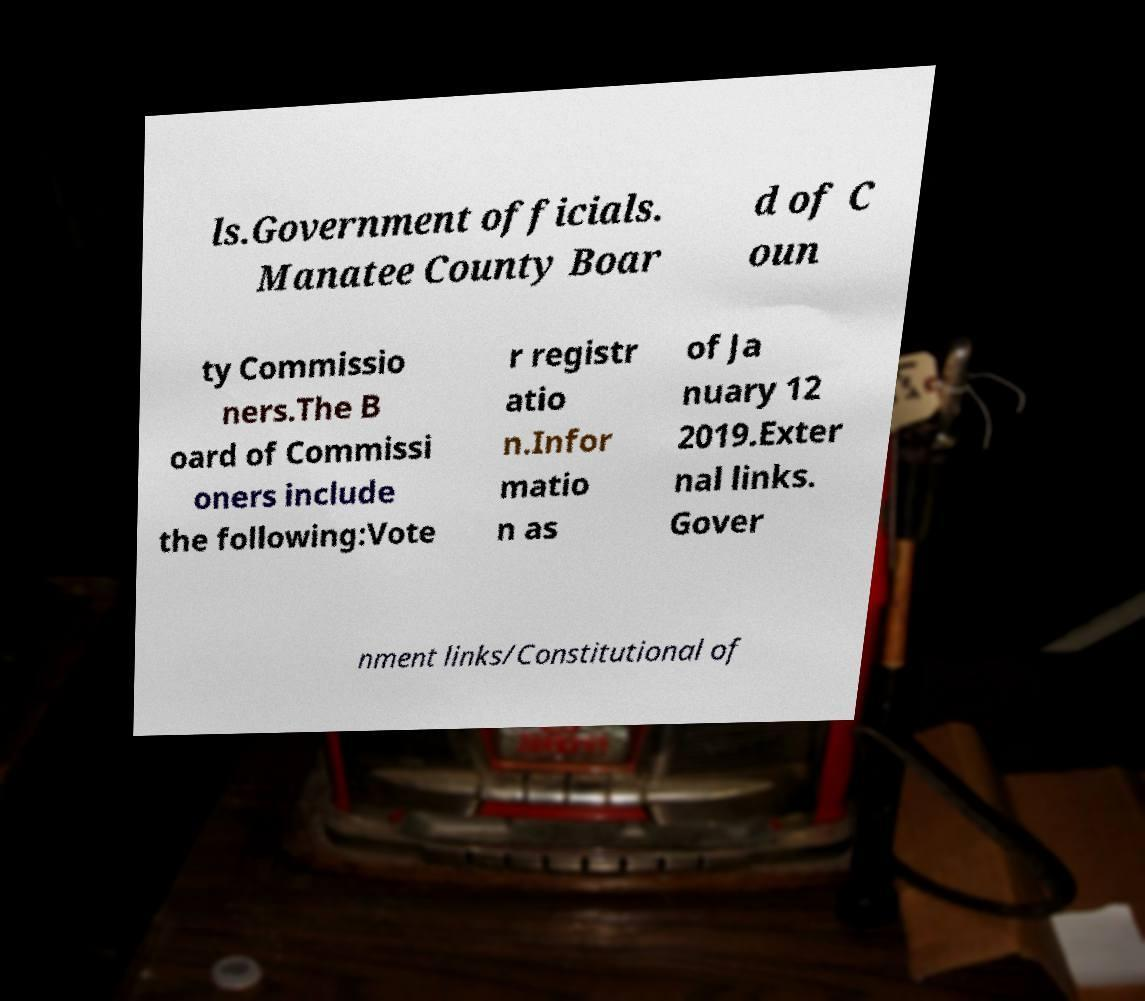Could you extract and type out the text from this image? ls.Government officials. Manatee County Boar d of C oun ty Commissio ners.The B oard of Commissi oners include the following:Vote r registr atio n.Infor matio n as of Ja nuary 12 2019.Exter nal links. Gover nment links/Constitutional of 